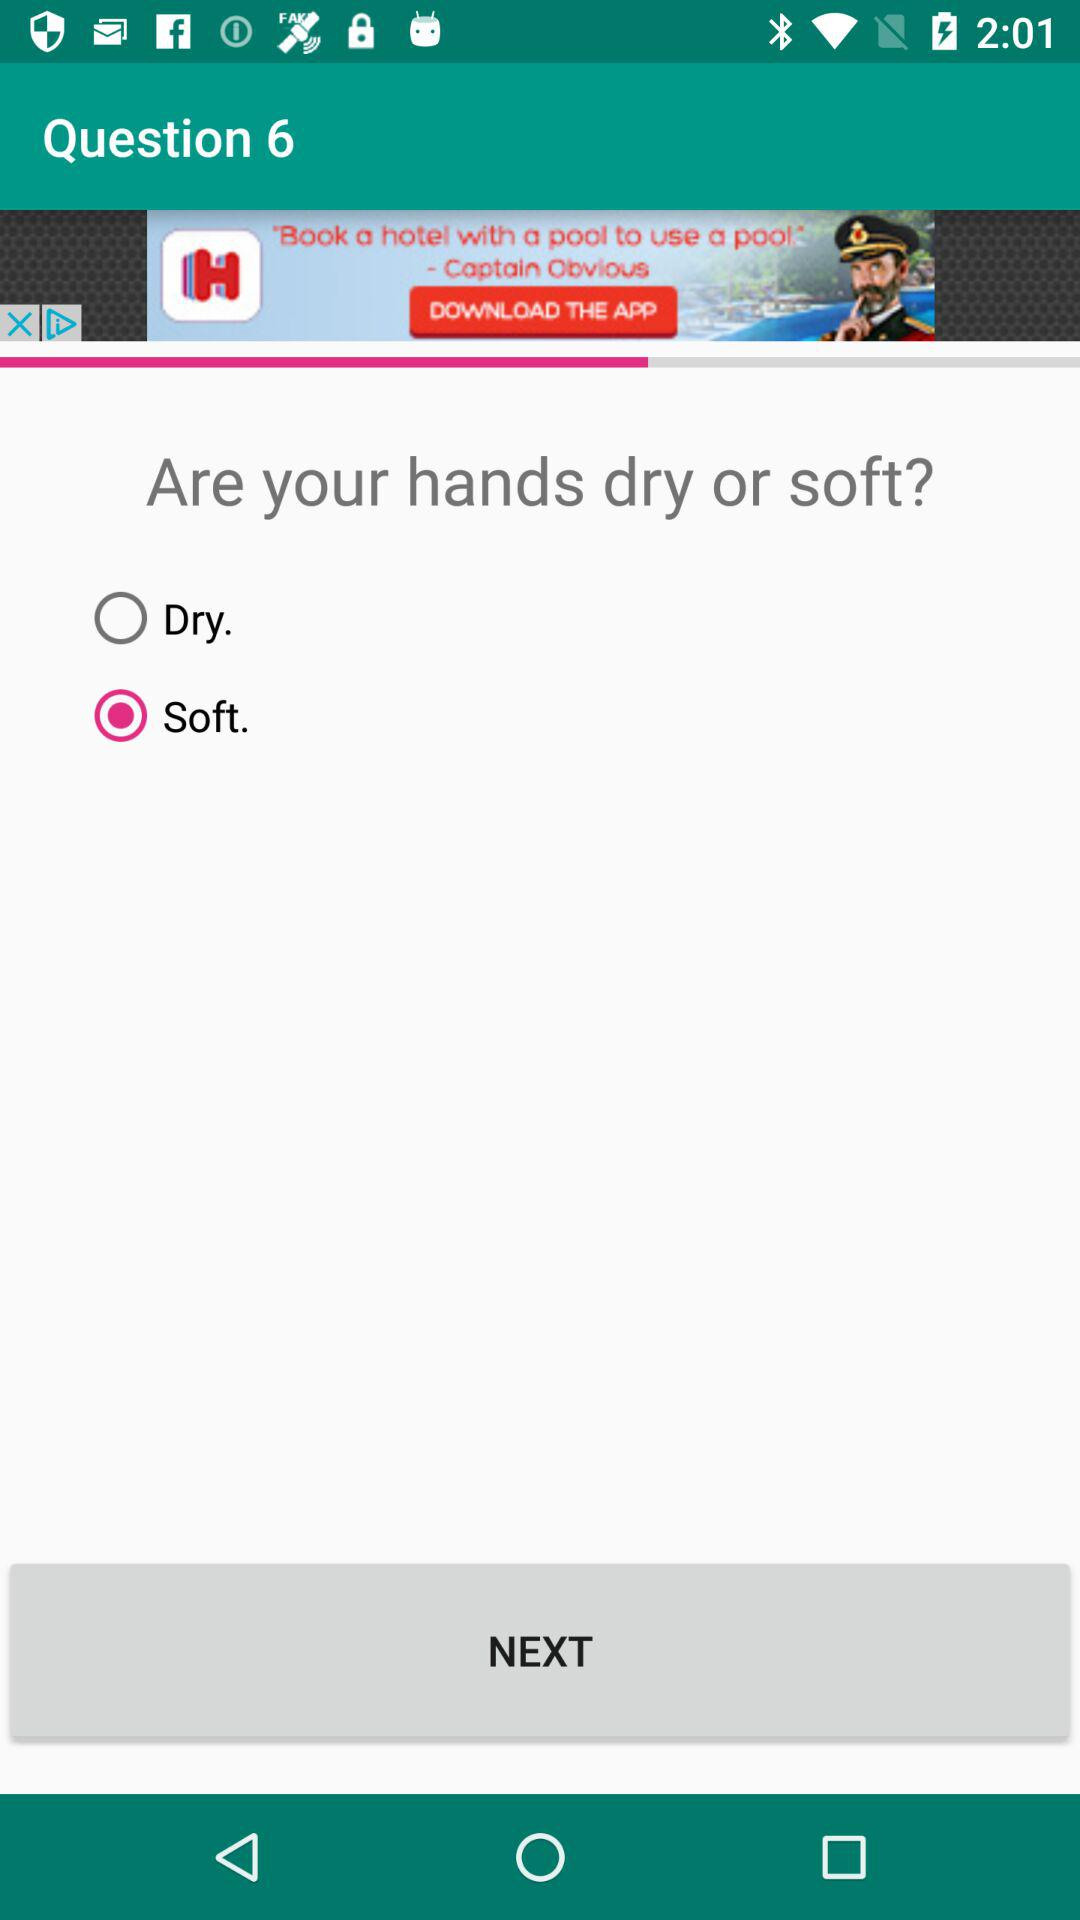Which option is selected? The selected option is "Soft". 